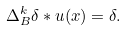<formula> <loc_0><loc_0><loc_500><loc_500>\Delta _ { B } ^ { k } \delta \ast u ( x ) = \delta .</formula> 